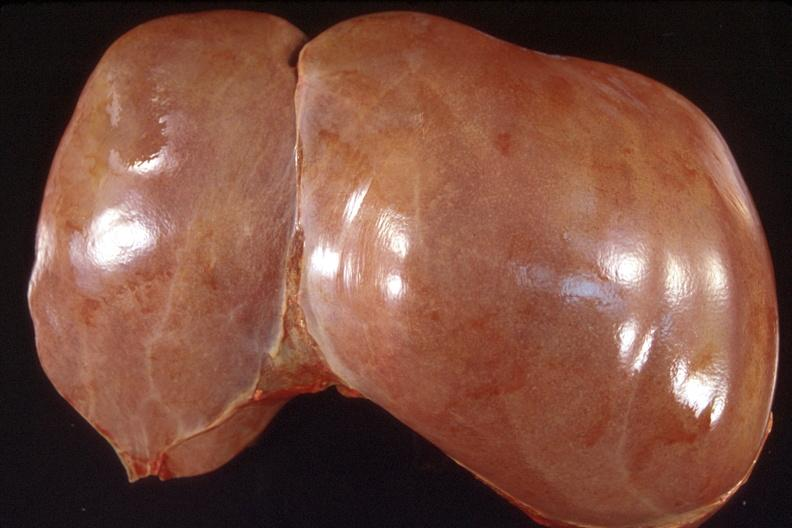s section of spleen through hilum present?
Answer the question using a single word or phrase. No 